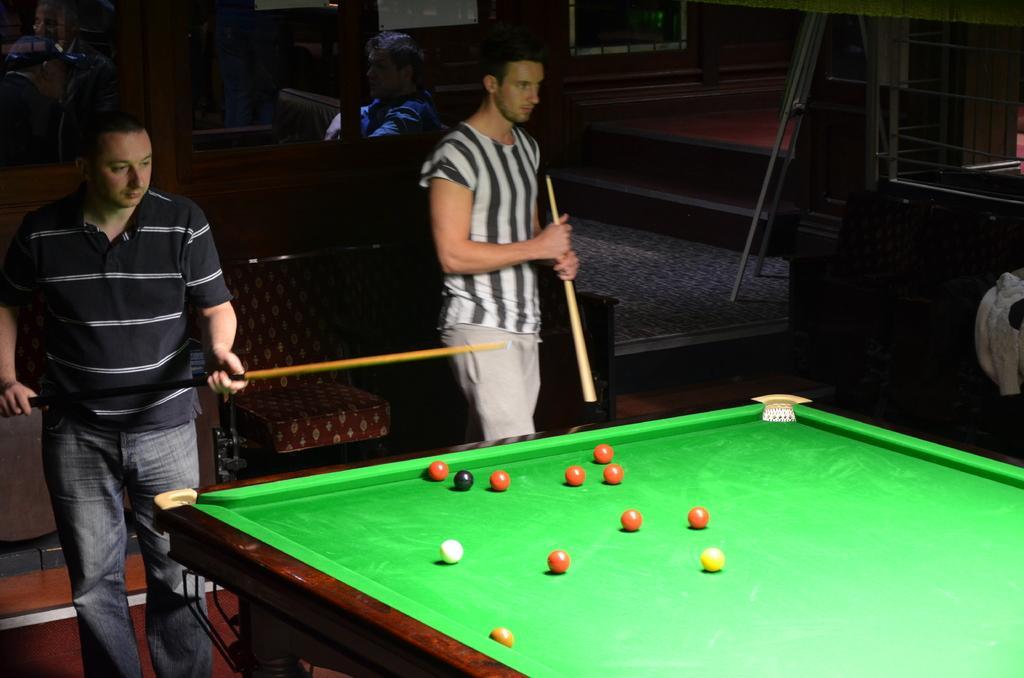Please provide a concise description of this image. The two persons are standing. They are holding a sticks. In background another person is a sitting behind him. There is a snooker board in middle with balls in it. We can see in background photo frame,wall and stand. 